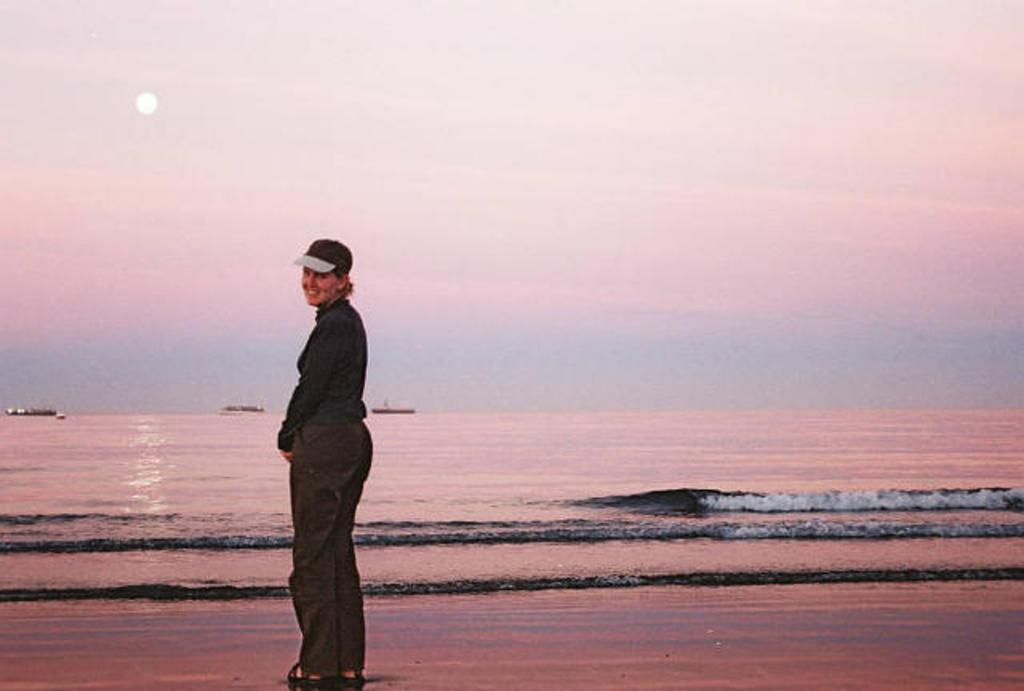Who is present in the image? There is a woman in the image. What is the woman doing in the image? The woman is standing and smiling. What can be seen in the background of the image? There is a sea visible in the image, and three boats are sailing on the sea. What type of knife is the woman using to cut her sandwich in the lunchroom? There is no lunchroom or sandwich present in the image, and the woman is not using a knife. 